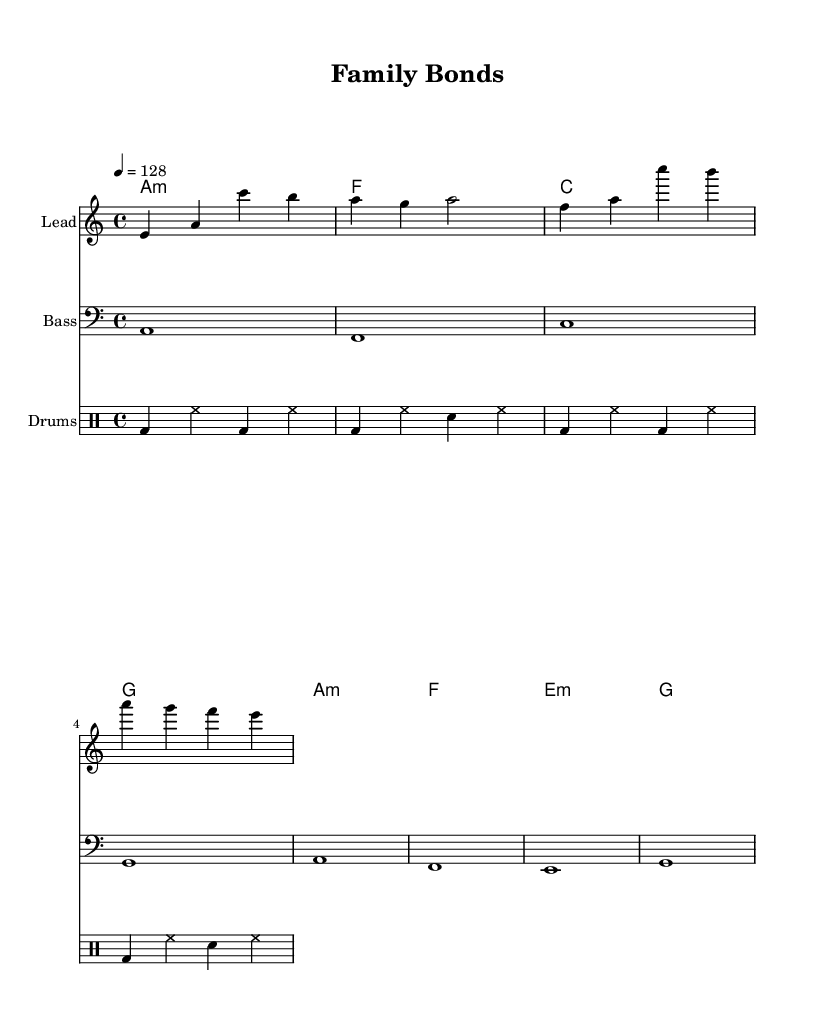What is the key signature of this music? The key signature is indicated by the presence of one flat, which corresponds to the key of A minor.
Answer: A minor What is the time signature of this piece? The time signature is indicated at the beginning of the sheet music, showing that it is in a 4/4 format which means four beats per measure.
Answer: 4/4 What is the tempo marking provided? The tempo marking states "4 = 128," which indicates the tempo in beats per minute.
Answer: 128 How many measures are there in the melody? By counting the measures in the melody line, we find there are four measures of music present.
Answer: 4 What is the chord progression used in the harmonies? The sequence of chords from the harmonies can be analyzed: A minor, F major, C major, and G major, returning to A minor again.
Answer: A minor, F, C, G Which instrument represents the bass? The bass line is notated on a separate staff indicating it plays a low range, and it also uses the bass clef.
Answer: Bass What style of music does this sheet music represent? The overall structure, tempo, and electronic beats suggest this sheet music is in the genre of melodic progressive house, focusing on themes of family and relationships.
Answer: Melodic progressive house 